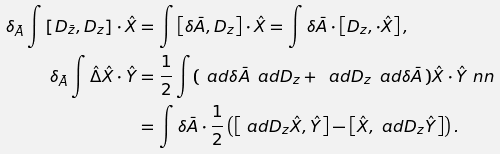<formula> <loc_0><loc_0><loc_500><loc_500>\delta _ { \bar { A } } \int \left [ D _ { \bar { z } } , D _ { z } \right ] \cdot \hat { X } & = \int \left [ \delta \bar { A } , D _ { z } \right ] \cdot \hat { X } = \int \delta \bar { A } \cdot \left [ D _ { z } , \cdot \hat { X } \right ] , \\ \delta _ { \bar { A } } \int \hat { \Delta } \hat { X } \cdot \hat { Y } & = \frac { 1 } { 2 } \int ( \, \ a d \delta \bar { A } \, \ a d D _ { z } + \, \ a d D _ { z } \, \ a d \delta \bar { A } \, ) \hat { X } \cdot \hat { Y } \ n n \\ & = \int \delta \bar { A } \cdot \frac { 1 } { 2 } \left ( \left [ \ a d D _ { z } \hat { X } , \hat { Y } \right ] - \left [ \hat { X } , \ a d D _ { z } \hat { Y } \right ] \right ) .</formula> 